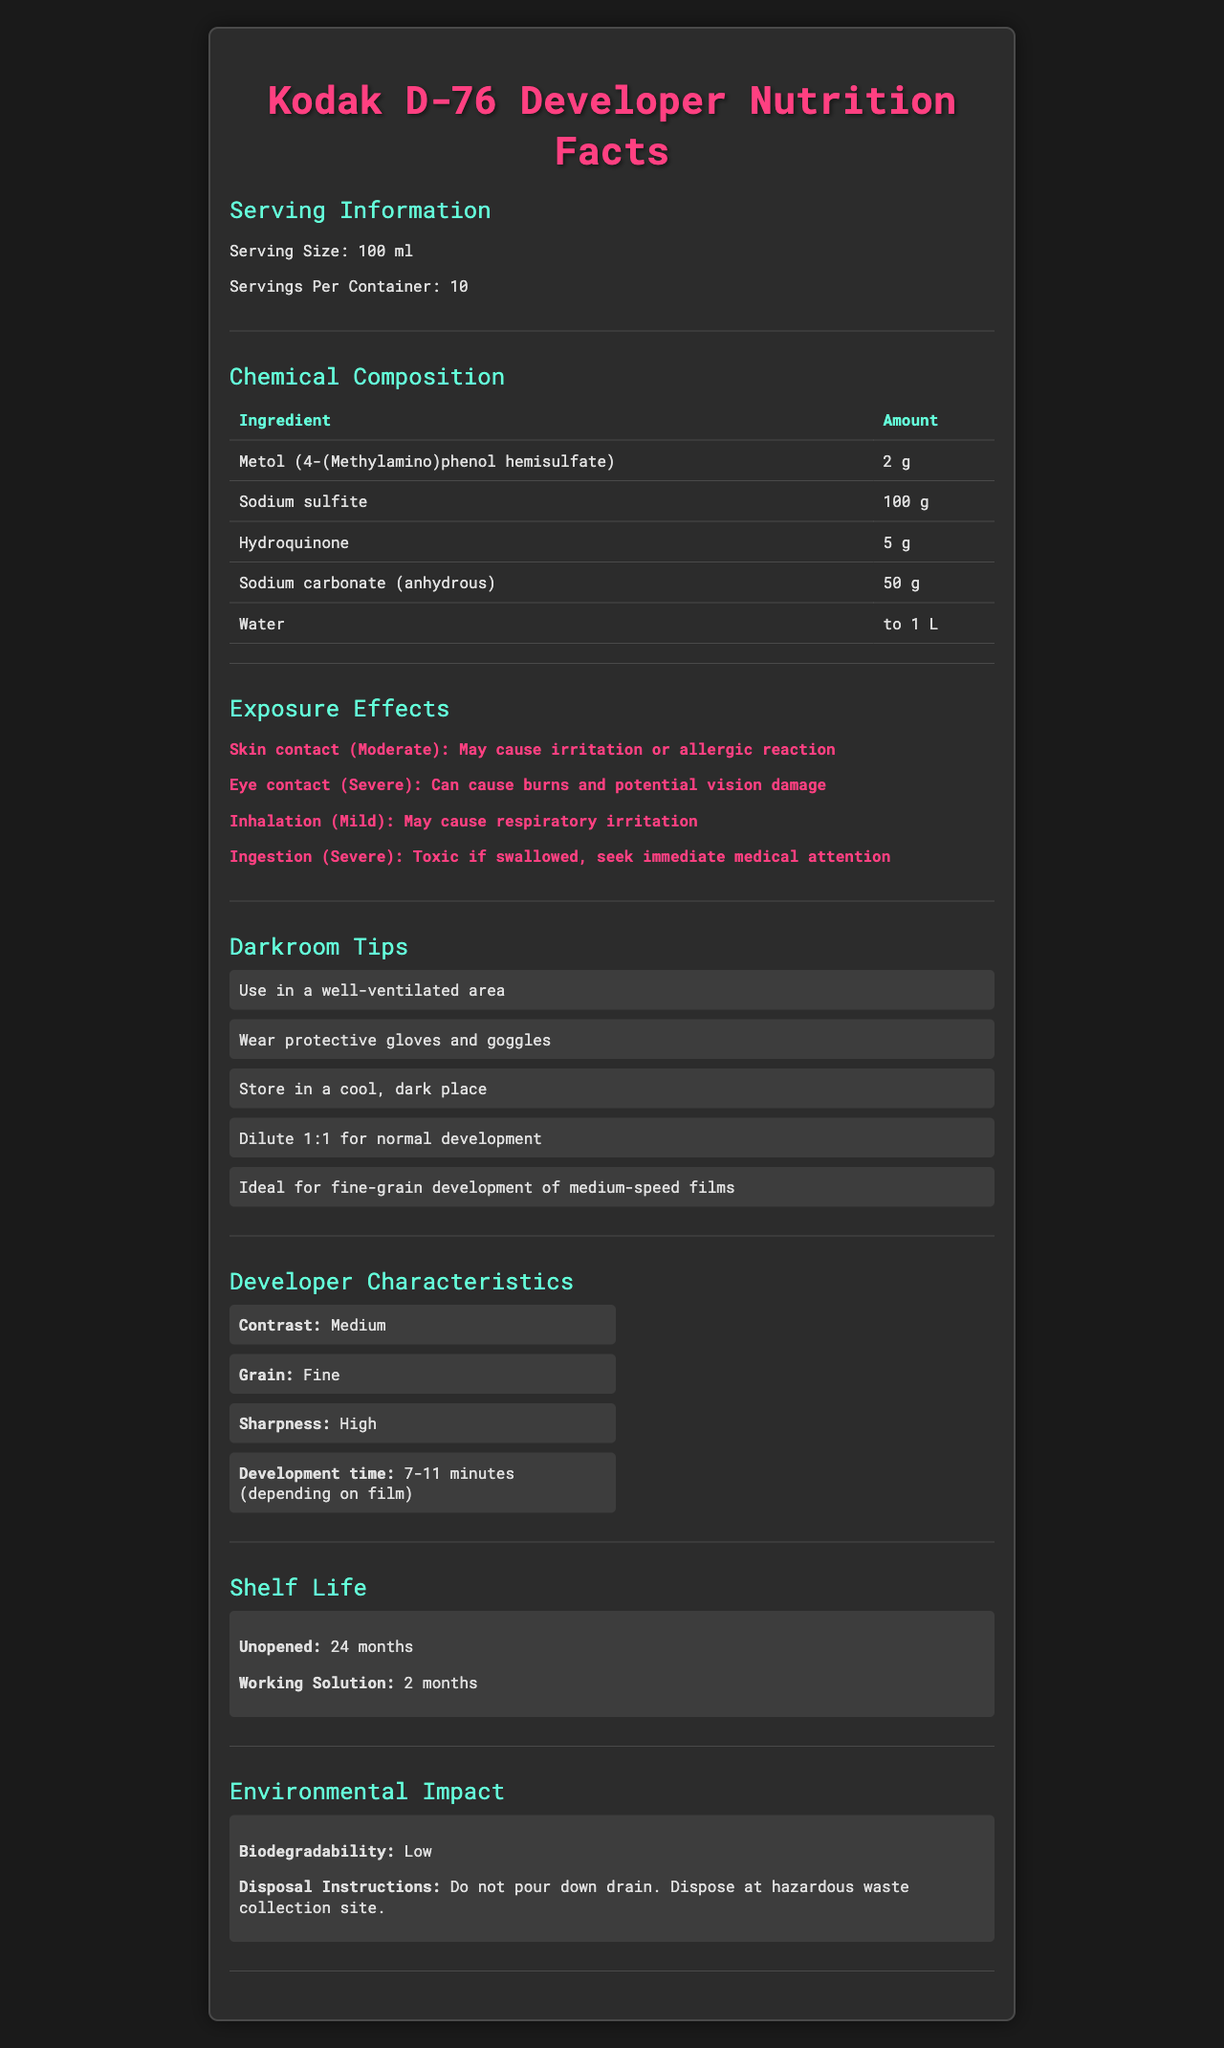what is the serving size for Kodak D-76 Developer? The serving size is listed under the "Serving Information" section as "100 ml."
Answer: 100 ml How many servings are there per container of Kodak D-76 Developer? The document specifies "Servings Per Container" as 10 under the "Serving Information" section.
Answer: 10 Which ingredient is present in the largest amount in the Kodak D-76 Developer? The chemical composition table lists Sodium sulfite with an amount of 100 g, which is the largest among the listed ingredients.
Answer: Sodium sulfite What are the exposure effects of ingesting the Kodak D-76 Developer? The exposure effects section mentions that ingestion has a severe effect and is toxic if swallowed, recommending immediate medical attention.
Answer: Severe, Toxic if swallowed, seek immediate medical attention What should you do to mitigate skin contact with Kodak D-76 Developer? One of the darkroom tips advises wearing protective gloves to mitigate skin contact.
Answer: Wear protective gloves What is the correct dilution ratio for normal development of the Kodak D-76 Developer? The darkroom tips section suggests diluting the developer 1:1 for normal development.
Answer: 1:1 Multiple-choice: What is the shelf life of an unopened Kodak D-76 Developer? A) 12 months B) 24 months C) 36 months D) 48 months The shelf life section specifies that an unopened container has a shelf life of 24 months.
Answer: B) 24 months Multiple-choice: Which characteristic of the Kodak D-76 Developer is described as "High"? i) Contrast ii) Grain iii) Sharpness iv) Development time The developer characteristics section lists "Sharpness" as being "High."
Answer: iii) Sharpness True/False: The Kodak D-76 Developer is highly biodegradable. The environmental impact section states that the developer has "Low" biodegradability.
Answer: False Summarize the main characteristics and safety guidelines for Kodak D-76 Developer. The main characteristics and safety guidelines are drawn from various sections that detail its chemical composition, usage tips, characteristics, shelf life, and environmental impact.
Answer: Kodak D-76 Developer is a medium contrast, fine-grain developer with high sharpness. It should be used in well-ventilated areas, with protective gloves and goggles. It has moderate to severe exposure effects and should be stored in cool, dark places. The unopened shelf life is 24 months, and it is not biodegradable; it requires special disposal methods. What is the price of Kodak D-76 Developer? The document does not provide any information about the price of the Kodak D-76 Developer.
Answer: Cannot be determined For which types of film is Kodak D-76 Developer ideally used? The darkroom tips section mentions that Kodak D-76 Developer is ideal for developing medium-speed films.
Answer: Medium-speed films 